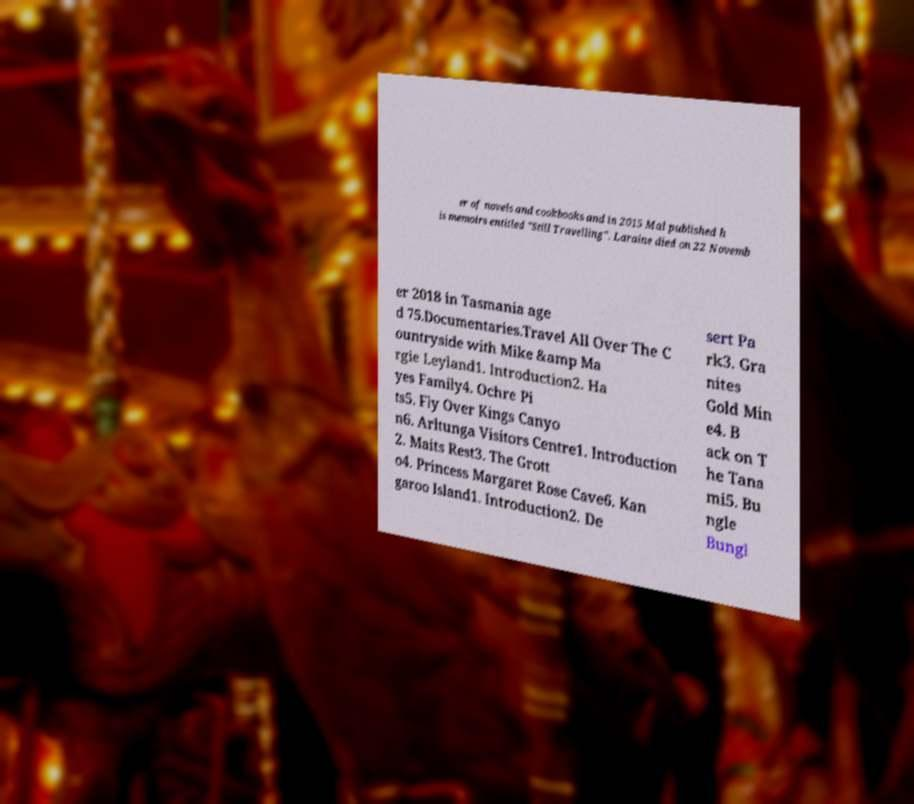There's text embedded in this image that I need extracted. Can you transcribe it verbatim? er of novels and cookbooks and in 2015 Mal published h is memoirs entitled "Still Travelling". Laraine died on 22 Novemb er 2018 in Tasmania age d 75.Documentaries.Travel All Over The C ountryside with Mike &amp Ma rgie Leyland1. Introduction2. Ha yes Family4. Ochre Pi ts5. Fly Over Kings Canyo n6. Arltunga Visitors Centre1. Introduction 2. Maits Rest3. The Grott o4. Princess Margaret Rose Cave6. Kan garoo Island1. Introduction2. De sert Pa rk3. Gra nites Gold Min e4. B ack on T he Tana mi5. Bu ngle Bungl 